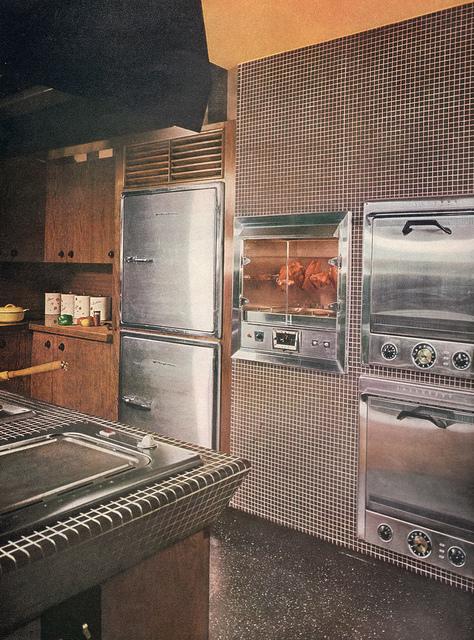Is this a restaurant kitchen?
Concise answer only. Yes. What room is this?
Quick response, please. Kitchen. Where was this photo taken?
Short answer required. Kitchen. 